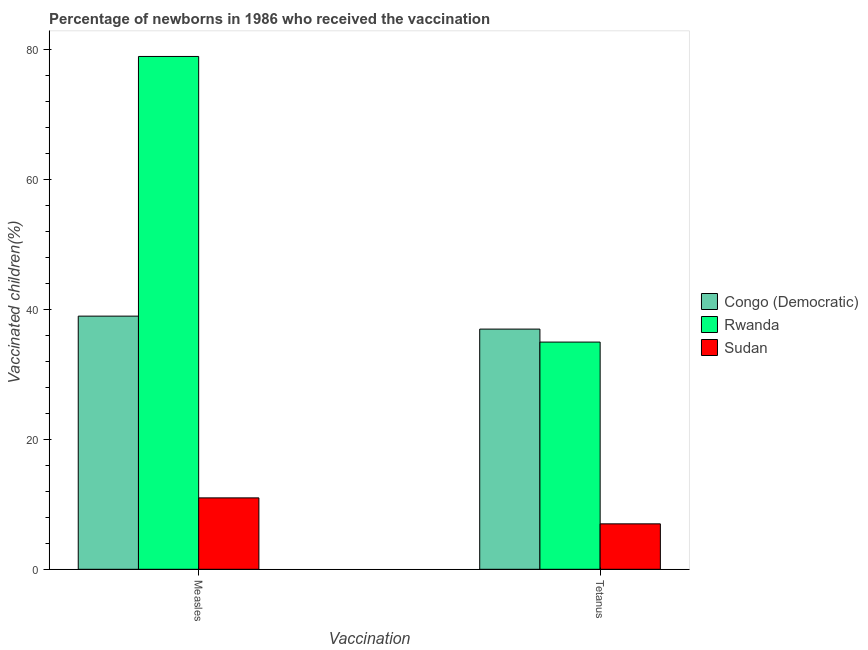Are the number of bars per tick equal to the number of legend labels?
Ensure brevity in your answer.  Yes. Are the number of bars on each tick of the X-axis equal?
Provide a short and direct response. Yes. How many bars are there on the 1st tick from the left?
Make the answer very short. 3. What is the label of the 1st group of bars from the left?
Your answer should be compact. Measles. What is the percentage of newborns who received vaccination for tetanus in Sudan?
Offer a terse response. 7. Across all countries, what is the maximum percentage of newborns who received vaccination for tetanus?
Ensure brevity in your answer.  37. Across all countries, what is the minimum percentage of newborns who received vaccination for tetanus?
Your response must be concise. 7. In which country was the percentage of newborns who received vaccination for tetanus maximum?
Offer a terse response. Congo (Democratic). In which country was the percentage of newborns who received vaccination for tetanus minimum?
Offer a terse response. Sudan. What is the total percentage of newborns who received vaccination for measles in the graph?
Provide a short and direct response. 129. What is the difference between the percentage of newborns who received vaccination for measles in Congo (Democratic) and that in Sudan?
Offer a very short reply. 28. What is the difference between the percentage of newborns who received vaccination for tetanus in Rwanda and the percentage of newborns who received vaccination for measles in Congo (Democratic)?
Make the answer very short. -4. What is the average percentage of newborns who received vaccination for measles per country?
Give a very brief answer. 43. What is the difference between the percentage of newborns who received vaccination for tetanus and percentage of newborns who received vaccination for measles in Sudan?
Offer a very short reply. -4. In how many countries, is the percentage of newborns who received vaccination for tetanus greater than 24 %?
Your response must be concise. 2. What is the ratio of the percentage of newborns who received vaccination for tetanus in Congo (Democratic) to that in Sudan?
Your response must be concise. 5.29. What does the 2nd bar from the left in Measles represents?
Keep it short and to the point. Rwanda. What does the 3rd bar from the right in Tetanus represents?
Your answer should be compact. Congo (Democratic). Are all the bars in the graph horizontal?
Your answer should be compact. No. What is the difference between two consecutive major ticks on the Y-axis?
Your response must be concise. 20. Does the graph contain grids?
Your answer should be compact. No. Where does the legend appear in the graph?
Keep it short and to the point. Center right. What is the title of the graph?
Make the answer very short. Percentage of newborns in 1986 who received the vaccination. What is the label or title of the X-axis?
Offer a terse response. Vaccination. What is the label or title of the Y-axis?
Keep it short and to the point. Vaccinated children(%)
. What is the Vaccinated children(%)
 in Rwanda in Measles?
Offer a terse response. 79. What is the Vaccinated children(%)
 of Congo (Democratic) in Tetanus?
Provide a succinct answer. 37. What is the Vaccinated children(%)
 in Rwanda in Tetanus?
Make the answer very short. 35. Across all Vaccination, what is the maximum Vaccinated children(%)
 of Congo (Democratic)?
Provide a short and direct response. 39. Across all Vaccination, what is the maximum Vaccinated children(%)
 in Rwanda?
Ensure brevity in your answer.  79. Across all Vaccination, what is the maximum Vaccinated children(%)
 of Sudan?
Provide a short and direct response. 11. Across all Vaccination, what is the minimum Vaccinated children(%)
 of Congo (Democratic)?
Your answer should be very brief. 37. Across all Vaccination, what is the minimum Vaccinated children(%)
 of Rwanda?
Keep it short and to the point. 35. Across all Vaccination, what is the minimum Vaccinated children(%)
 of Sudan?
Your answer should be very brief. 7. What is the total Vaccinated children(%)
 of Congo (Democratic) in the graph?
Give a very brief answer. 76. What is the total Vaccinated children(%)
 in Rwanda in the graph?
Ensure brevity in your answer.  114. What is the total Vaccinated children(%)
 in Sudan in the graph?
Make the answer very short. 18. What is the difference between the Vaccinated children(%)
 in Sudan in Measles and that in Tetanus?
Your answer should be compact. 4. What is the average Vaccinated children(%)
 in Rwanda per Vaccination?
Keep it short and to the point. 57. What is the difference between the Vaccinated children(%)
 of Congo (Democratic) and Vaccinated children(%)
 of Rwanda in Measles?
Ensure brevity in your answer.  -40. What is the difference between the Vaccinated children(%)
 of Rwanda and Vaccinated children(%)
 of Sudan in Measles?
Make the answer very short. 68. What is the difference between the Vaccinated children(%)
 in Congo (Democratic) and Vaccinated children(%)
 in Rwanda in Tetanus?
Make the answer very short. 2. What is the ratio of the Vaccinated children(%)
 in Congo (Democratic) in Measles to that in Tetanus?
Your answer should be very brief. 1.05. What is the ratio of the Vaccinated children(%)
 of Rwanda in Measles to that in Tetanus?
Your answer should be very brief. 2.26. What is the ratio of the Vaccinated children(%)
 of Sudan in Measles to that in Tetanus?
Make the answer very short. 1.57. What is the difference between the highest and the second highest Vaccinated children(%)
 of Congo (Democratic)?
Your answer should be very brief. 2. What is the difference between the highest and the second highest Vaccinated children(%)
 in Sudan?
Make the answer very short. 4. What is the difference between the highest and the lowest Vaccinated children(%)
 of Rwanda?
Your answer should be very brief. 44. What is the difference between the highest and the lowest Vaccinated children(%)
 in Sudan?
Your answer should be compact. 4. 